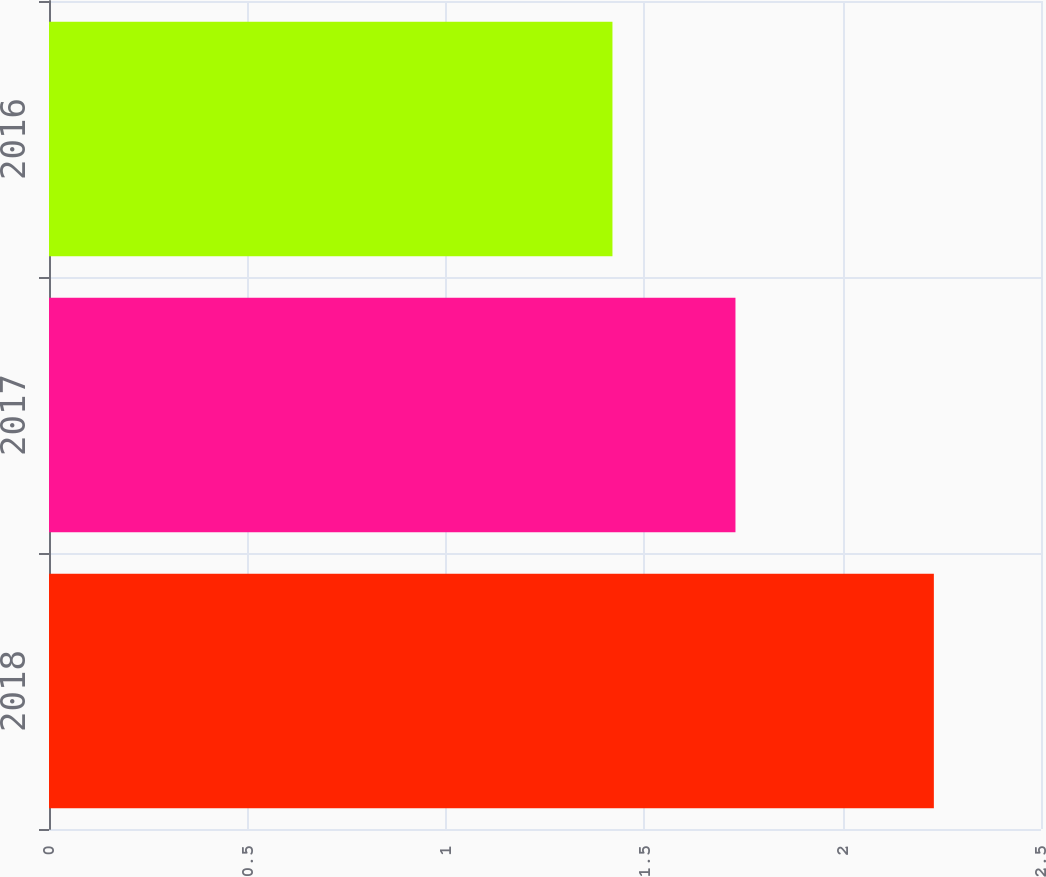<chart> <loc_0><loc_0><loc_500><loc_500><bar_chart><fcel>2018<fcel>2017<fcel>2016<nl><fcel>2.23<fcel>1.73<fcel>1.42<nl></chart> 